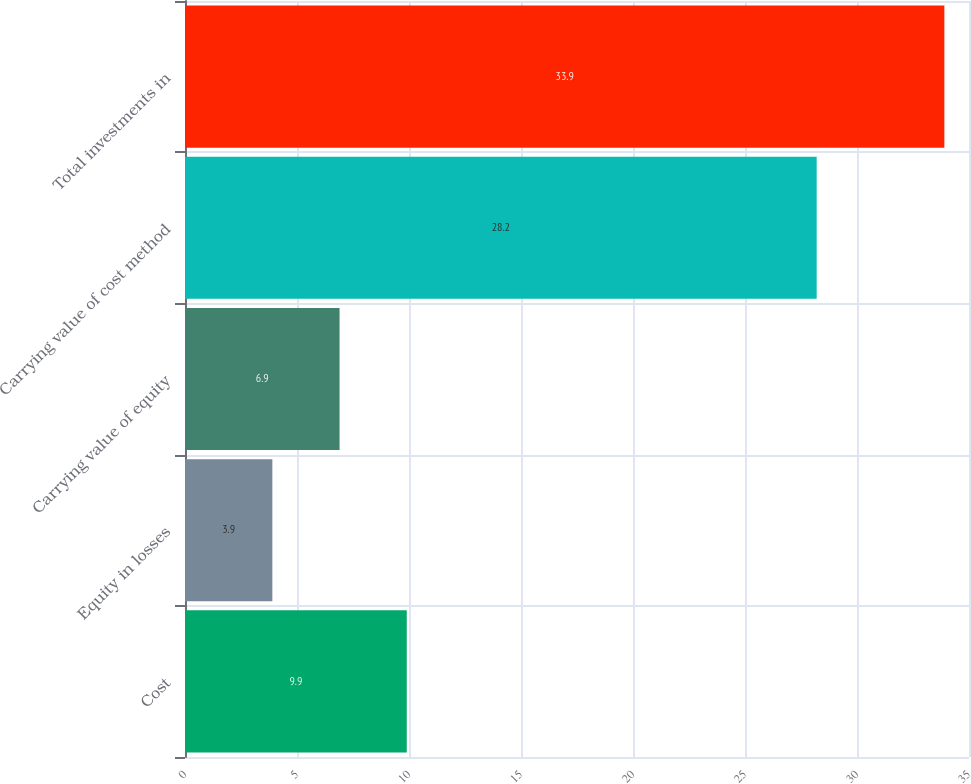Convert chart to OTSL. <chart><loc_0><loc_0><loc_500><loc_500><bar_chart><fcel>Cost<fcel>Equity in losses<fcel>Carrying value of equity<fcel>Carrying value of cost method<fcel>Total investments in<nl><fcel>9.9<fcel>3.9<fcel>6.9<fcel>28.2<fcel>33.9<nl></chart> 